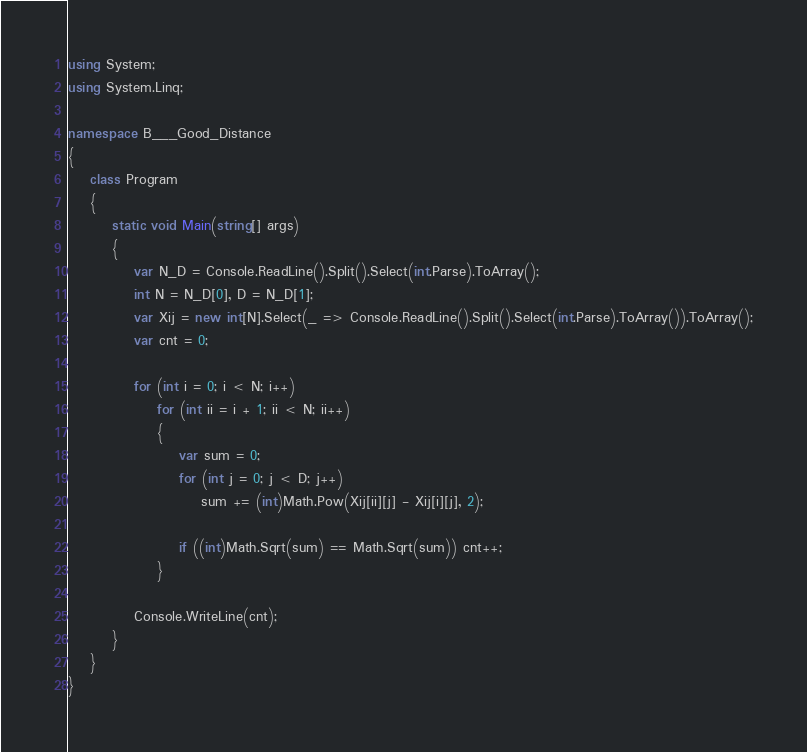<code> <loc_0><loc_0><loc_500><loc_500><_C#_>using System;
using System.Linq;

namespace B___Good_Distance
{
    class Program
    {
        static void Main(string[] args)
        {
            var N_D = Console.ReadLine().Split().Select(int.Parse).ToArray();
            int N = N_D[0], D = N_D[1];
            var Xij = new int[N].Select(_ => Console.ReadLine().Split().Select(int.Parse).ToArray()).ToArray();
            var cnt = 0;

            for (int i = 0; i < N; i++)
                for (int ii = i + 1; ii < N; ii++)
                {
                    var sum = 0;
                    for (int j = 0; j < D; j++)
                        sum += (int)Math.Pow(Xij[ii][j] - Xij[i][j], 2);

                    if ((int)Math.Sqrt(sum) == Math.Sqrt(sum)) cnt++;
                }

            Console.WriteLine(cnt);
        }
    }
}
</code> 